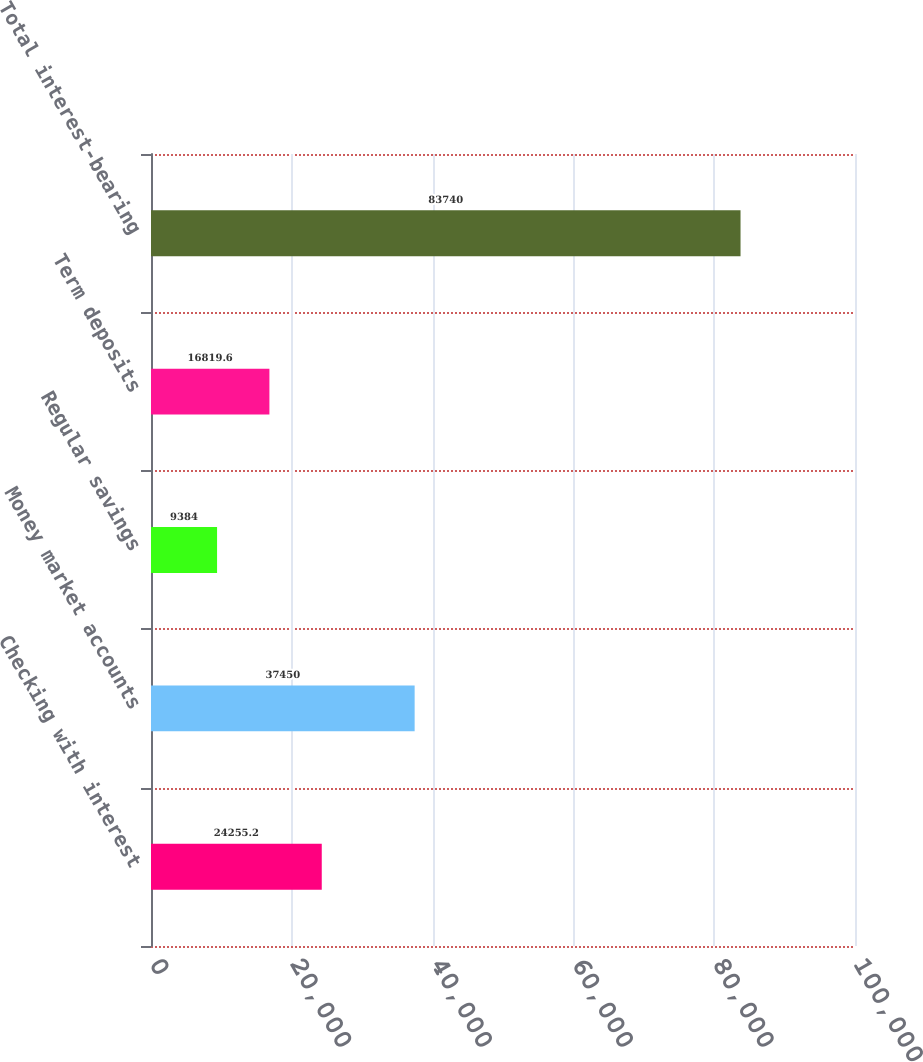Convert chart to OTSL. <chart><loc_0><loc_0><loc_500><loc_500><bar_chart><fcel>Checking with interest<fcel>Money market accounts<fcel>Regular savings<fcel>Term deposits<fcel>Total interest-bearing<nl><fcel>24255.2<fcel>37450<fcel>9384<fcel>16819.6<fcel>83740<nl></chart> 